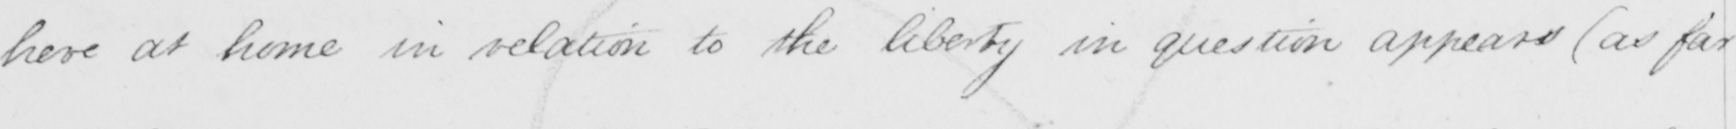Please transcribe the handwritten text in this image. here at home in relation to the liberty in question appears  ( as far 